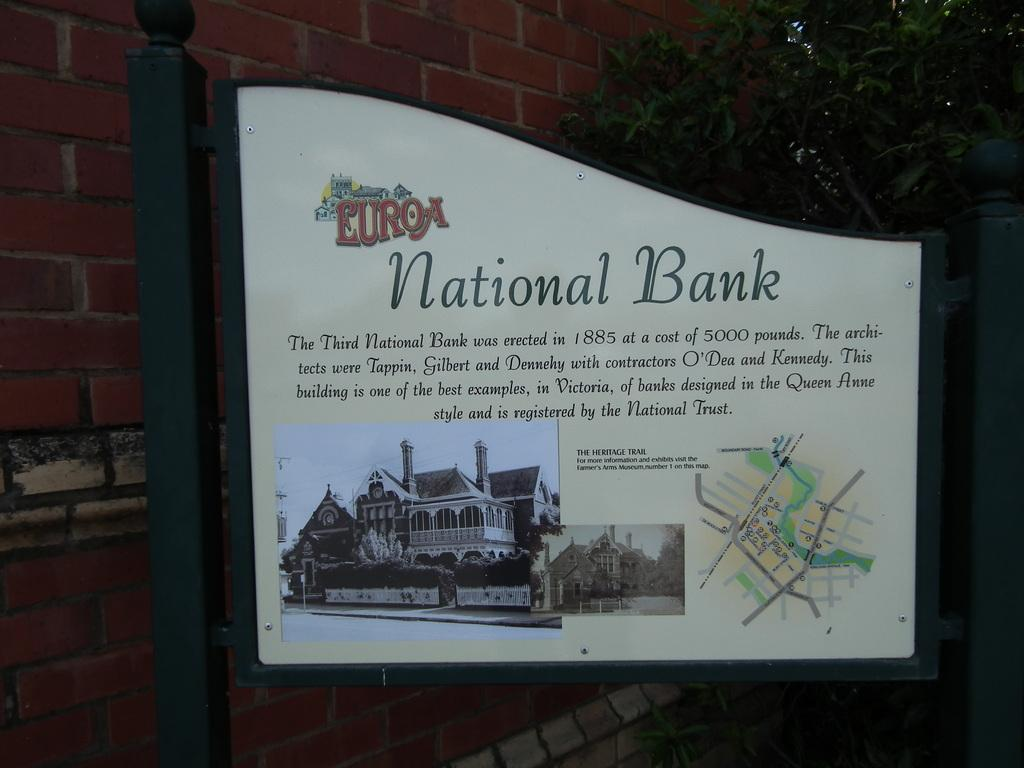<image>
Relay a brief, clear account of the picture shown. the entrance board which shows the details of Euroa National Bank with the oldest picture and  location map 